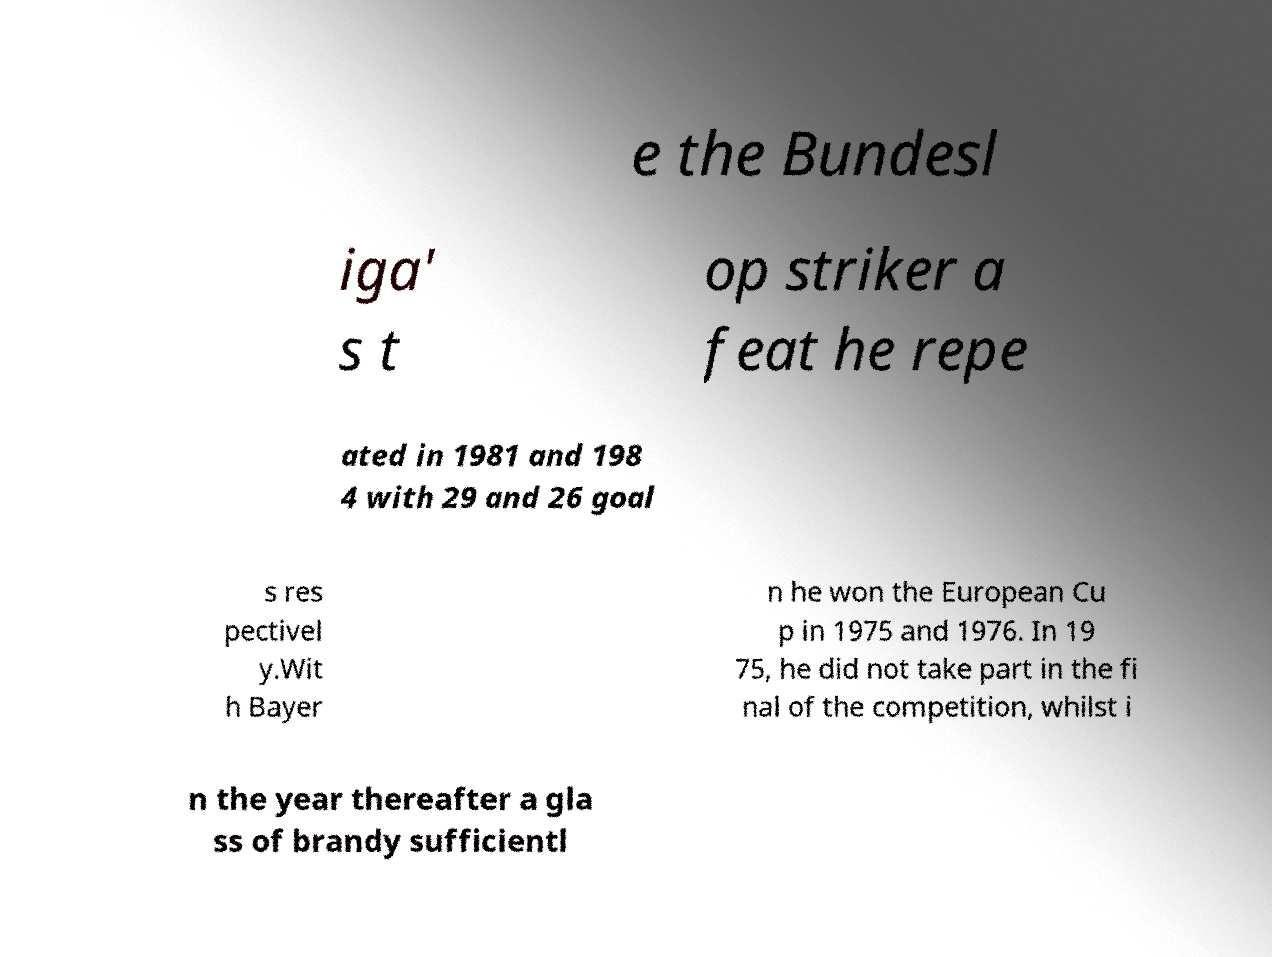Please read and relay the text visible in this image. What does it say? e the Bundesl iga' s t op striker a feat he repe ated in 1981 and 198 4 with 29 and 26 goal s res pectivel y.Wit h Bayer n he won the European Cu p in 1975 and 1976. In 19 75, he did not take part in the fi nal of the competition, whilst i n the year thereafter a gla ss of brandy sufficientl 